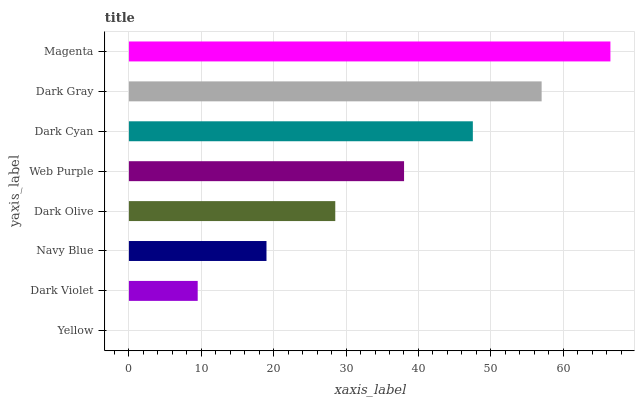Is Yellow the minimum?
Answer yes or no. Yes. Is Magenta the maximum?
Answer yes or no. Yes. Is Dark Violet the minimum?
Answer yes or no. No. Is Dark Violet the maximum?
Answer yes or no. No. Is Dark Violet greater than Yellow?
Answer yes or no. Yes. Is Yellow less than Dark Violet?
Answer yes or no. Yes. Is Yellow greater than Dark Violet?
Answer yes or no. No. Is Dark Violet less than Yellow?
Answer yes or no. No. Is Web Purple the high median?
Answer yes or no. Yes. Is Dark Olive the low median?
Answer yes or no. Yes. Is Dark Cyan the high median?
Answer yes or no. No. Is Dark Violet the low median?
Answer yes or no. No. 